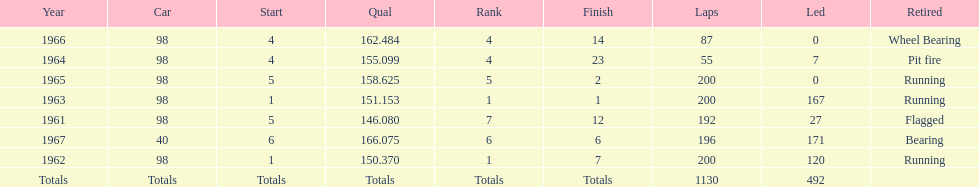What is the most common cause for a retired car? Running. 